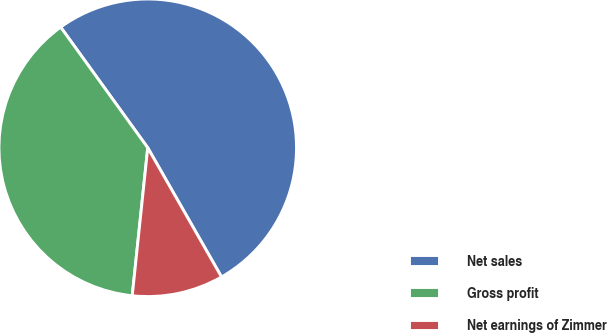Convert chart to OTSL. <chart><loc_0><loc_0><loc_500><loc_500><pie_chart><fcel>Net sales<fcel>Gross profit<fcel>Net earnings of Zimmer<nl><fcel>51.69%<fcel>38.39%<fcel>9.92%<nl></chart> 